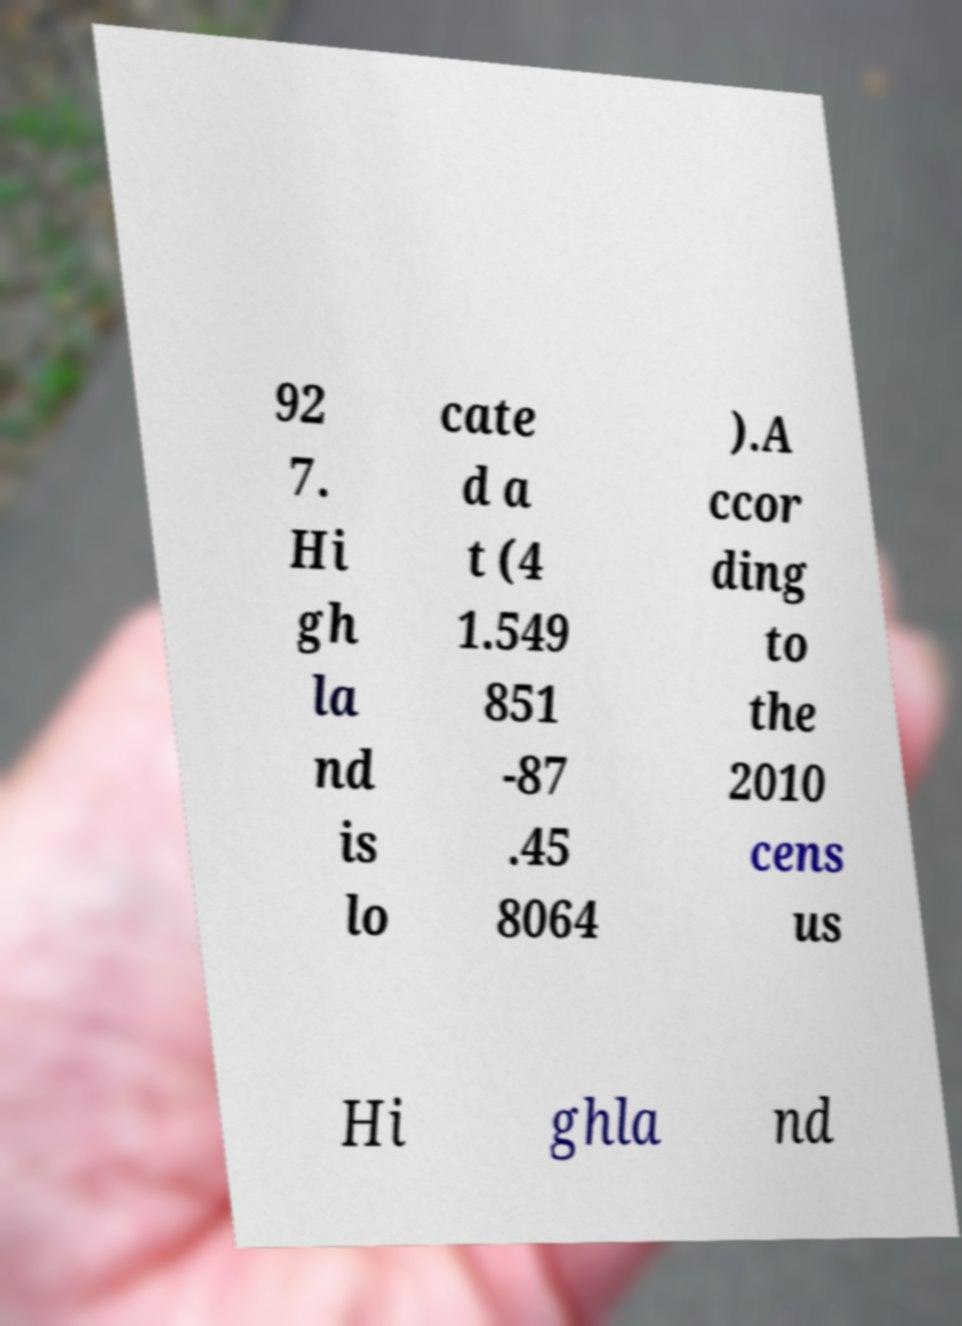Can you read and provide the text displayed in the image?This photo seems to have some interesting text. Can you extract and type it out for me? 92 7. Hi gh la nd is lo cate d a t (4 1.549 851 -87 .45 8064 ).A ccor ding to the 2010 cens us Hi ghla nd 